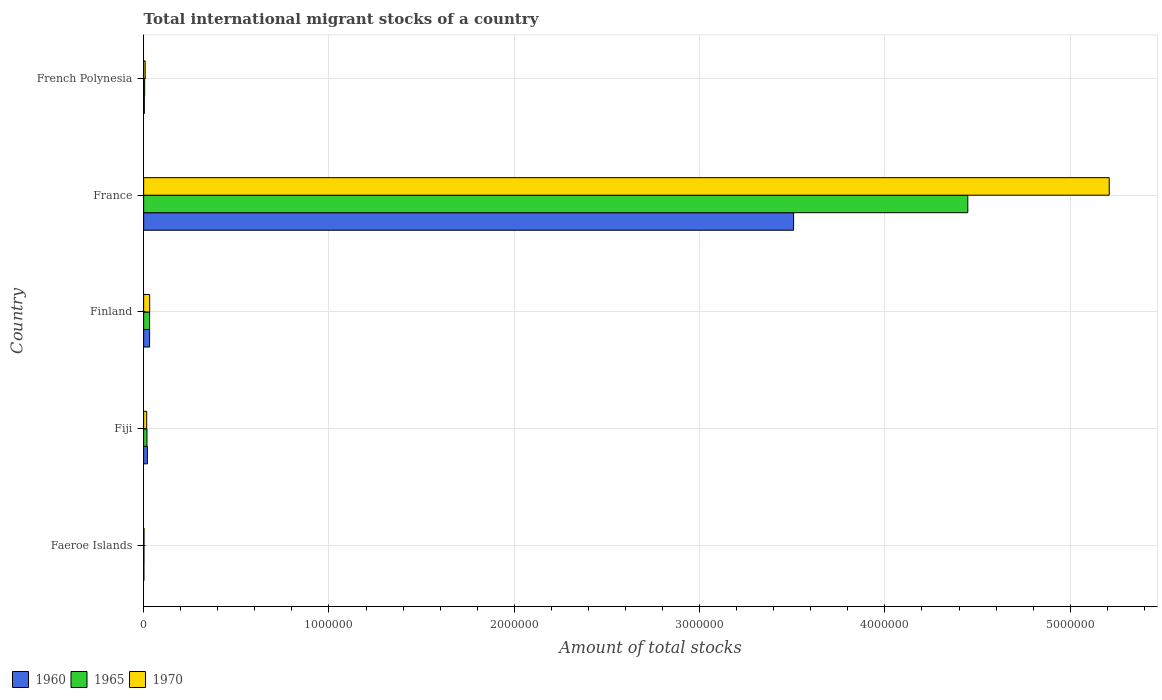How many groups of bars are there?
Your answer should be compact. 5. How many bars are there on the 1st tick from the top?
Give a very brief answer. 3. What is the label of the 1st group of bars from the top?
Offer a terse response. French Polynesia. In how many cases, is the number of bars for a given country not equal to the number of legend labels?
Ensure brevity in your answer.  0. What is the amount of total stocks in in 1960 in France?
Your response must be concise. 3.51e+06. Across all countries, what is the maximum amount of total stocks in in 1960?
Provide a short and direct response. 3.51e+06. Across all countries, what is the minimum amount of total stocks in in 1970?
Make the answer very short. 1978. In which country was the amount of total stocks in in 1965 maximum?
Give a very brief answer. France. In which country was the amount of total stocks in in 1965 minimum?
Give a very brief answer. Faeroe Islands. What is the total amount of total stocks in in 1965 in the graph?
Offer a terse response. 4.50e+06. What is the difference between the amount of total stocks in in 1970 in Faeroe Islands and that in Finland?
Provide a short and direct response. -3.05e+04. What is the difference between the amount of total stocks in in 1960 in Faeroe Islands and the amount of total stocks in in 1970 in Fiji?
Make the answer very short. -1.49e+04. What is the average amount of total stocks in in 1960 per country?
Provide a succinct answer. 7.13e+05. What is the difference between the amount of total stocks in in 1960 and amount of total stocks in in 1970 in Fiji?
Make the answer very short. 3684. What is the ratio of the amount of total stocks in in 1960 in Fiji to that in Finland?
Offer a terse response. 0.63. What is the difference between the highest and the second highest amount of total stocks in in 1965?
Provide a short and direct response. 4.42e+06. What is the difference between the highest and the lowest amount of total stocks in in 1965?
Your answer should be compact. 4.45e+06. In how many countries, is the amount of total stocks in in 1970 greater than the average amount of total stocks in in 1970 taken over all countries?
Offer a very short reply. 1. Is the sum of the amount of total stocks in in 1965 in Finland and French Polynesia greater than the maximum amount of total stocks in in 1970 across all countries?
Provide a succinct answer. No. What does the 2nd bar from the bottom in Fiji represents?
Keep it short and to the point. 1965. How many bars are there?
Provide a succinct answer. 15. Are all the bars in the graph horizontal?
Give a very brief answer. Yes. How many countries are there in the graph?
Provide a succinct answer. 5. What is the difference between two consecutive major ticks on the X-axis?
Make the answer very short. 1.00e+06. Are the values on the major ticks of X-axis written in scientific E-notation?
Provide a short and direct response. No. Does the graph contain grids?
Ensure brevity in your answer.  Yes. Where does the legend appear in the graph?
Keep it short and to the point. Bottom left. How are the legend labels stacked?
Keep it short and to the point. Horizontal. What is the title of the graph?
Provide a succinct answer. Total international migrant stocks of a country. Does "1980" appear as one of the legend labels in the graph?
Your response must be concise. No. What is the label or title of the X-axis?
Make the answer very short. Amount of total stocks. What is the Amount of total stocks of 1960 in Faeroe Islands?
Provide a succinct answer. 1489. What is the Amount of total stocks in 1965 in Faeroe Islands?
Your response must be concise. 1716. What is the Amount of total stocks in 1970 in Faeroe Islands?
Make the answer very short. 1978. What is the Amount of total stocks of 1960 in Fiji?
Provide a succinct answer. 2.01e+04. What is the Amount of total stocks of 1965 in Fiji?
Provide a short and direct response. 1.80e+04. What is the Amount of total stocks of 1970 in Fiji?
Offer a very short reply. 1.64e+04. What is the Amount of total stocks of 1960 in Finland?
Your response must be concise. 3.21e+04. What is the Amount of total stocks of 1965 in Finland?
Keep it short and to the point. 3.22e+04. What is the Amount of total stocks of 1970 in Finland?
Offer a terse response. 3.25e+04. What is the Amount of total stocks of 1960 in France?
Provide a short and direct response. 3.51e+06. What is the Amount of total stocks of 1965 in France?
Offer a very short reply. 4.45e+06. What is the Amount of total stocks in 1970 in France?
Your answer should be compact. 5.21e+06. What is the Amount of total stocks in 1960 in French Polynesia?
Provide a short and direct response. 3665. What is the Amount of total stocks in 1965 in French Polynesia?
Your answer should be compact. 5480. What is the Amount of total stocks in 1970 in French Polynesia?
Ensure brevity in your answer.  8194. Across all countries, what is the maximum Amount of total stocks in 1960?
Your response must be concise. 3.51e+06. Across all countries, what is the maximum Amount of total stocks of 1965?
Provide a short and direct response. 4.45e+06. Across all countries, what is the maximum Amount of total stocks of 1970?
Provide a short and direct response. 5.21e+06. Across all countries, what is the minimum Amount of total stocks in 1960?
Ensure brevity in your answer.  1489. Across all countries, what is the minimum Amount of total stocks of 1965?
Offer a terse response. 1716. Across all countries, what is the minimum Amount of total stocks of 1970?
Your response must be concise. 1978. What is the total Amount of total stocks in 1960 in the graph?
Your response must be concise. 3.56e+06. What is the total Amount of total stocks of 1965 in the graph?
Ensure brevity in your answer.  4.50e+06. What is the total Amount of total stocks in 1970 in the graph?
Provide a succinct answer. 5.27e+06. What is the difference between the Amount of total stocks of 1960 in Faeroe Islands and that in Fiji?
Provide a short and direct response. -1.86e+04. What is the difference between the Amount of total stocks of 1965 in Faeroe Islands and that in Fiji?
Provide a short and direct response. -1.62e+04. What is the difference between the Amount of total stocks of 1970 in Faeroe Islands and that in Fiji?
Your answer should be compact. -1.44e+04. What is the difference between the Amount of total stocks of 1960 in Faeroe Islands and that in Finland?
Give a very brief answer. -3.06e+04. What is the difference between the Amount of total stocks in 1965 in Faeroe Islands and that in Finland?
Your answer should be compact. -3.05e+04. What is the difference between the Amount of total stocks in 1970 in Faeroe Islands and that in Finland?
Provide a short and direct response. -3.05e+04. What is the difference between the Amount of total stocks of 1960 in Faeroe Islands and that in France?
Ensure brevity in your answer.  -3.51e+06. What is the difference between the Amount of total stocks in 1965 in Faeroe Islands and that in France?
Offer a very short reply. -4.45e+06. What is the difference between the Amount of total stocks in 1970 in Faeroe Islands and that in France?
Your response must be concise. -5.21e+06. What is the difference between the Amount of total stocks in 1960 in Faeroe Islands and that in French Polynesia?
Keep it short and to the point. -2176. What is the difference between the Amount of total stocks of 1965 in Faeroe Islands and that in French Polynesia?
Provide a succinct answer. -3764. What is the difference between the Amount of total stocks of 1970 in Faeroe Islands and that in French Polynesia?
Make the answer very short. -6216. What is the difference between the Amount of total stocks in 1960 in Fiji and that in Finland?
Your answer should be very brief. -1.20e+04. What is the difference between the Amount of total stocks in 1965 in Fiji and that in Finland?
Your answer should be compact. -1.42e+04. What is the difference between the Amount of total stocks in 1970 in Fiji and that in Finland?
Ensure brevity in your answer.  -1.61e+04. What is the difference between the Amount of total stocks of 1960 in Fiji and that in France?
Ensure brevity in your answer.  -3.49e+06. What is the difference between the Amount of total stocks of 1965 in Fiji and that in France?
Ensure brevity in your answer.  -4.43e+06. What is the difference between the Amount of total stocks of 1970 in Fiji and that in France?
Your answer should be very brief. -5.19e+06. What is the difference between the Amount of total stocks of 1960 in Fiji and that in French Polynesia?
Your answer should be compact. 1.64e+04. What is the difference between the Amount of total stocks in 1965 in Fiji and that in French Polynesia?
Your answer should be very brief. 1.25e+04. What is the difference between the Amount of total stocks of 1970 in Fiji and that in French Polynesia?
Make the answer very short. 8200. What is the difference between the Amount of total stocks in 1960 in Finland and that in France?
Offer a terse response. -3.48e+06. What is the difference between the Amount of total stocks of 1965 in Finland and that in France?
Offer a very short reply. -4.42e+06. What is the difference between the Amount of total stocks in 1970 in Finland and that in France?
Make the answer very short. -5.18e+06. What is the difference between the Amount of total stocks of 1960 in Finland and that in French Polynesia?
Offer a terse response. 2.84e+04. What is the difference between the Amount of total stocks of 1965 in Finland and that in French Polynesia?
Provide a succinct answer. 2.67e+04. What is the difference between the Amount of total stocks of 1970 in Finland and that in French Polynesia?
Your response must be concise. 2.43e+04. What is the difference between the Amount of total stocks of 1960 in France and that in French Polynesia?
Make the answer very short. 3.50e+06. What is the difference between the Amount of total stocks in 1965 in France and that in French Polynesia?
Offer a very short reply. 4.44e+06. What is the difference between the Amount of total stocks of 1970 in France and that in French Polynesia?
Ensure brevity in your answer.  5.20e+06. What is the difference between the Amount of total stocks of 1960 in Faeroe Islands and the Amount of total stocks of 1965 in Fiji?
Your response must be concise. -1.65e+04. What is the difference between the Amount of total stocks of 1960 in Faeroe Islands and the Amount of total stocks of 1970 in Fiji?
Your response must be concise. -1.49e+04. What is the difference between the Amount of total stocks of 1965 in Faeroe Islands and the Amount of total stocks of 1970 in Fiji?
Provide a short and direct response. -1.47e+04. What is the difference between the Amount of total stocks in 1960 in Faeroe Islands and the Amount of total stocks in 1965 in Finland?
Give a very brief answer. -3.07e+04. What is the difference between the Amount of total stocks of 1960 in Faeroe Islands and the Amount of total stocks of 1970 in Finland?
Your answer should be compact. -3.10e+04. What is the difference between the Amount of total stocks in 1965 in Faeroe Islands and the Amount of total stocks in 1970 in Finland?
Ensure brevity in your answer.  -3.08e+04. What is the difference between the Amount of total stocks in 1960 in Faeroe Islands and the Amount of total stocks in 1965 in France?
Your answer should be compact. -4.45e+06. What is the difference between the Amount of total stocks of 1960 in Faeroe Islands and the Amount of total stocks of 1970 in France?
Offer a terse response. -5.21e+06. What is the difference between the Amount of total stocks of 1965 in Faeroe Islands and the Amount of total stocks of 1970 in France?
Offer a terse response. -5.21e+06. What is the difference between the Amount of total stocks of 1960 in Faeroe Islands and the Amount of total stocks of 1965 in French Polynesia?
Make the answer very short. -3991. What is the difference between the Amount of total stocks of 1960 in Faeroe Islands and the Amount of total stocks of 1970 in French Polynesia?
Ensure brevity in your answer.  -6705. What is the difference between the Amount of total stocks of 1965 in Faeroe Islands and the Amount of total stocks of 1970 in French Polynesia?
Provide a short and direct response. -6478. What is the difference between the Amount of total stocks in 1960 in Fiji and the Amount of total stocks in 1965 in Finland?
Give a very brief answer. -1.21e+04. What is the difference between the Amount of total stocks in 1960 in Fiji and the Amount of total stocks in 1970 in Finland?
Keep it short and to the point. -1.24e+04. What is the difference between the Amount of total stocks in 1965 in Fiji and the Amount of total stocks in 1970 in Finland?
Your answer should be compact. -1.45e+04. What is the difference between the Amount of total stocks in 1960 in Fiji and the Amount of total stocks in 1965 in France?
Give a very brief answer. -4.43e+06. What is the difference between the Amount of total stocks in 1960 in Fiji and the Amount of total stocks in 1970 in France?
Keep it short and to the point. -5.19e+06. What is the difference between the Amount of total stocks in 1965 in Fiji and the Amount of total stocks in 1970 in France?
Provide a short and direct response. -5.19e+06. What is the difference between the Amount of total stocks in 1960 in Fiji and the Amount of total stocks in 1965 in French Polynesia?
Keep it short and to the point. 1.46e+04. What is the difference between the Amount of total stocks in 1960 in Fiji and the Amount of total stocks in 1970 in French Polynesia?
Ensure brevity in your answer.  1.19e+04. What is the difference between the Amount of total stocks of 1965 in Fiji and the Amount of total stocks of 1970 in French Polynesia?
Your answer should be very brief. 9759. What is the difference between the Amount of total stocks of 1960 in Finland and the Amount of total stocks of 1965 in France?
Ensure brevity in your answer.  -4.42e+06. What is the difference between the Amount of total stocks of 1960 in Finland and the Amount of total stocks of 1970 in France?
Offer a very short reply. -5.18e+06. What is the difference between the Amount of total stocks of 1965 in Finland and the Amount of total stocks of 1970 in France?
Give a very brief answer. -5.18e+06. What is the difference between the Amount of total stocks of 1960 in Finland and the Amount of total stocks of 1965 in French Polynesia?
Offer a very short reply. 2.66e+04. What is the difference between the Amount of total stocks in 1960 in Finland and the Amount of total stocks in 1970 in French Polynesia?
Provide a short and direct response. 2.39e+04. What is the difference between the Amount of total stocks in 1965 in Finland and the Amount of total stocks in 1970 in French Polynesia?
Your answer should be compact. 2.40e+04. What is the difference between the Amount of total stocks of 1960 in France and the Amount of total stocks of 1965 in French Polynesia?
Your answer should be very brief. 3.50e+06. What is the difference between the Amount of total stocks of 1960 in France and the Amount of total stocks of 1970 in French Polynesia?
Offer a terse response. 3.50e+06. What is the difference between the Amount of total stocks of 1965 in France and the Amount of total stocks of 1970 in French Polynesia?
Your answer should be compact. 4.44e+06. What is the average Amount of total stocks in 1960 per country?
Make the answer very short. 7.13e+05. What is the average Amount of total stocks of 1965 per country?
Your response must be concise. 9.01e+05. What is the average Amount of total stocks of 1970 per country?
Give a very brief answer. 1.05e+06. What is the difference between the Amount of total stocks of 1960 and Amount of total stocks of 1965 in Faeroe Islands?
Your answer should be very brief. -227. What is the difference between the Amount of total stocks in 1960 and Amount of total stocks in 1970 in Faeroe Islands?
Ensure brevity in your answer.  -489. What is the difference between the Amount of total stocks in 1965 and Amount of total stocks in 1970 in Faeroe Islands?
Provide a succinct answer. -262. What is the difference between the Amount of total stocks of 1960 and Amount of total stocks of 1965 in Fiji?
Offer a terse response. 2125. What is the difference between the Amount of total stocks of 1960 and Amount of total stocks of 1970 in Fiji?
Keep it short and to the point. 3684. What is the difference between the Amount of total stocks in 1965 and Amount of total stocks in 1970 in Fiji?
Offer a terse response. 1559. What is the difference between the Amount of total stocks of 1960 and Amount of total stocks of 1965 in Finland?
Your response must be concise. -112. What is the difference between the Amount of total stocks in 1960 and Amount of total stocks in 1970 in Finland?
Provide a succinct answer. -407. What is the difference between the Amount of total stocks of 1965 and Amount of total stocks of 1970 in Finland?
Your answer should be very brief. -295. What is the difference between the Amount of total stocks of 1960 and Amount of total stocks of 1965 in France?
Your answer should be compact. -9.40e+05. What is the difference between the Amount of total stocks in 1960 and Amount of total stocks in 1970 in France?
Make the answer very short. -1.70e+06. What is the difference between the Amount of total stocks of 1965 and Amount of total stocks of 1970 in France?
Offer a terse response. -7.63e+05. What is the difference between the Amount of total stocks of 1960 and Amount of total stocks of 1965 in French Polynesia?
Give a very brief answer. -1815. What is the difference between the Amount of total stocks in 1960 and Amount of total stocks in 1970 in French Polynesia?
Provide a succinct answer. -4529. What is the difference between the Amount of total stocks in 1965 and Amount of total stocks in 1970 in French Polynesia?
Make the answer very short. -2714. What is the ratio of the Amount of total stocks in 1960 in Faeroe Islands to that in Fiji?
Your answer should be compact. 0.07. What is the ratio of the Amount of total stocks in 1965 in Faeroe Islands to that in Fiji?
Your answer should be very brief. 0.1. What is the ratio of the Amount of total stocks of 1970 in Faeroe Islands to that in Fiji?
Give a very brief answer. 0.12. What is the ratio of the Amount of total stocks in 1960 in Faeroe Islands to that in Finland?
Keep it short and to the point. 0.05. What is the ratio of the Amount of total stocks of 1965 in Faeroe Islands to that in Finland?
Offer a very short reply. 0.05. What is the ratio of the Amount of total stocks in 1970 in Faeroe Islands to that in Finland?
Provide a short and direct response. 0.06. What is the ratio of the Amount of total stocks in 1960 in Faeroe Islands to that in France?
Keep it short and to the point. 0. What is the ratio of the Amount of total stocks in 1965 in Faeroe Islands to that in France?
Offer a very short reply. 0. What is the ratio of the Amount of total stocks of 1960 in Faeroe Islands to that in French Polynesia?
Provide a short and direct response. 0.41. What is the ratio of the Amount of total stocks in 1965 in Faeroe Islands to that in French Polynesia?
Offer a terse response. 0.31. What is the ratio of the Amount of total stocks in 1970 in Faeroe Islands to that in French Polynesia?
Keep it short and to the point. 0.24. What is the ratio of the Amount of total stocks in 1960 in Fiji to that in Finland?
Make the answer very short. 0.63. What is the ratio of the Amount of total stocks of 1965 in Fiji to that in Finland?
Keep it short and to the point. 0.56. What is the ratio of the Amount of total stocks of 1970 in Fiji to that in Finland?
Keep it short and to the point. 0.5. What is the ratio of the Amount of total stocks in 1960 in Fiji to that in France?
Your answer should be compact. 0.01. What is the ratio of the Amount of total stocks of 1965 in Fiji to that in France?
Make the answer very short. 0. What is the ratio of the Amount of total stocks of 1970 in Fiji to that in France?
Make the answer very short. 0. What is the ratio of the Amount of total stocks of 1960 in Fiji to that in French Polynesia?
Your response must be concise. 5.48. What is the ratio of the Amount of total stocks in 1965 in Fiji to that in French Polynesia?
Offer a very short reply. 3.28. What is the ratio of the Amount of total stocks in 1970 in Fiji to that in French Polynesia?
Make the answer very short. 2. What is the ratio of the Amount of total stocks in 1960 in Finland to that in France?
Provide a short and direct response. 0.01. What is the ratio of the Amount of total stocks in 1965 in Finland to that in France?
Give a very brief answer. 0.01. What is the ratio of the Amount of total stocks in 1970 in Finland to that in France?
Ensure brevity in your answer.  0.01. What is the ratio of the Amount of total stocks of 1960 in Finland to that in French Polynesia?
Your answer should be very brief. 8.75. What is the ratio of the Amount of total stocks in 1965 in Finland to that in French Polynesia?
Keep it short and to the point. 5.88. What is the ratio of the Amount of total stocks in 1970 in Finland to that in French Polynesia?
Your answer should be compact. 3.97. What is the ratio of the Amount of total stocks in 1960 in France to that in French Polynesia?
Your answer should be very brief. 956.95. What is the ratio of the Amount of total stocks of 1965 in France to that in French Polynesia?
Make the answer very short. 811.54. What is the ratio of the Amount of total stocks of 1970 in France to that in French Polynesia?
Your answer should be very brief. 635.87. What is the difference between the highest and the second highest Amount of total stocks of 1960?
Your response must be concise. 3.48e+06. What is the difference between the highest and the second highest Amount of total stocks of 1965?
Provide a succinct answer. 4.42e+06. What is the difference between the highest and the second highest Amount of total stocks of 1970?
Your response must be concise. 5.18e+06. What is the difference between the highest and the lowest Amount of total stocks of 1960?
Your response must be concise. 3.51e+06. What is the difference between the highest and the lowest Amount of total stocks of 1965?
Your response must be concise. 4.45e+06. What is the difference between the highest and the lowest Amount of total stocks of 1970?
Make the answer very short. 5.21e+06. 